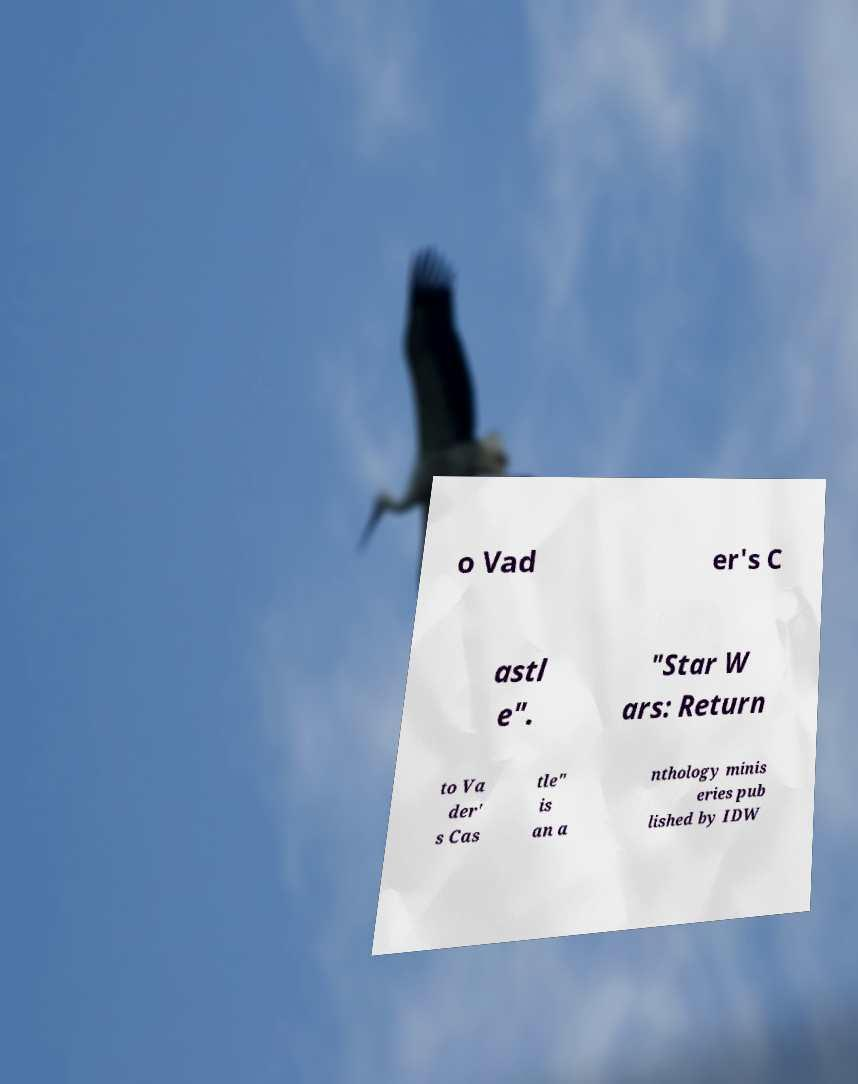Please identify and transcribe the text found in this image. o Vad er's C astl e". "Star W ars: Return to Va der' s Cas tle" is an a nthology minis eries pub lished by IDW 